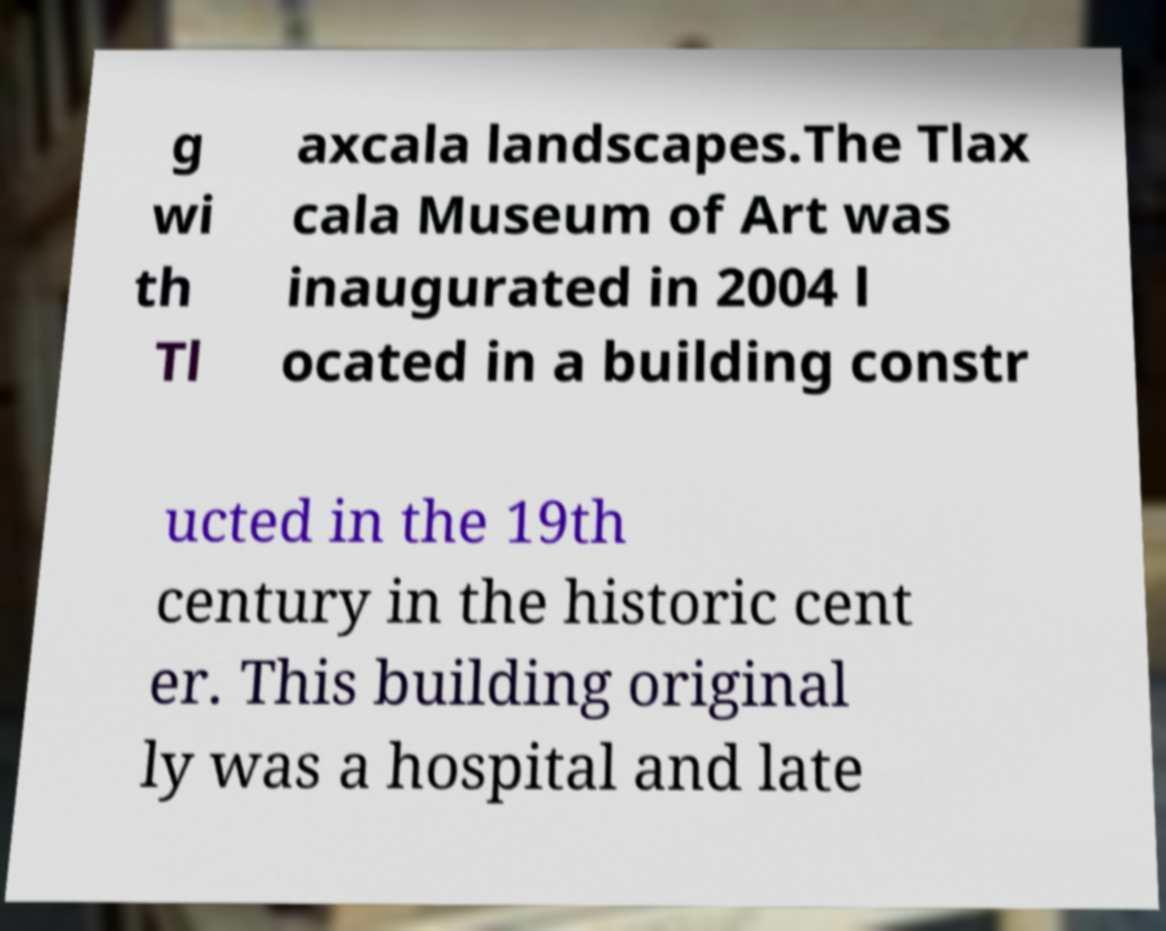Please identify and transcribe the text found in this image. g wi th Tl axcala landscapes.The Tlax cala Museum of Art was inaugurated in 2004 l ocated in a building constr ucted in the 19th century in the historic cent er. This building original ly was a hospital and late 